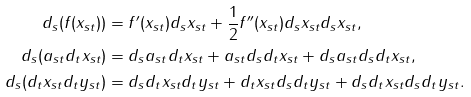<formula> <loc_0><loc_0><loc_500><loc_500>d _ { s } ( f ( x _ { s t } ) ) & = f ^ { \prime } ( x _ { s t } ) d _ { s } x _ { s t } + \frac { 1 } { 2 } f ^ { \prime \prime } ( x _ { s t } ) d _ { s } x _ { s t } d _ { s } x _ { s t } , \\ d _ { s } ( a _ { s t } d _ { t } x _ { s t } ) & = d _ { s } a _ { s t } d _ { t } x _ { s t } + a _ { s t } d _ { s } d _ { t } x _ { s t } + d _ { s } a _ { s t } d _ { s } d _ { t } x _ { s t } , \\ d _ { s } ( d _ { t } x _ { s t } d _ { t } y _ { s t } ) & = d _ { s } d _ { t } x _ { s t } d _ { t } y _ { s t } + d _ { t } x _ { s t } d _ { s } d _ { t } y _ { s t } + d _ { s } d _ { t } x _ { s t } d _ { s } d _ { t } y _ { s t } .</formula> 